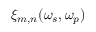Convert formula to latex. <formula><loc_0><loc_0><loc_500><loc_500>\xi _ { m , n } ( \omega _ { s } , \omega _ { p } )</formula> 